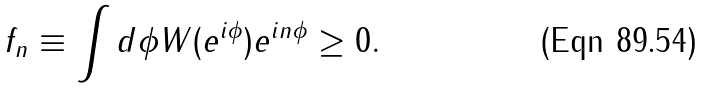<formula> <loc_0><loc_0><loc_500><loc_500>f _ { n } \equiv \int d \phi W ( e ^ { i \phi } ) e ^ { i n \phi } \geq 0 .</formula> 